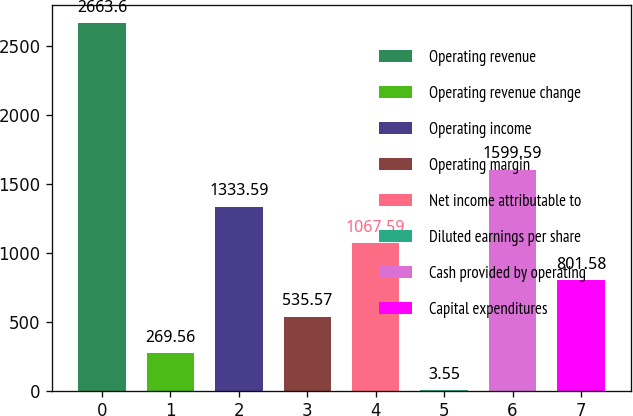<chart> <loc_0><loc_0><loc_500><loc_500><bar_chart><fcel>Operating revenue<fcel>Operating revenue change<fcel>Operating income<fcel>Operating margin<fcel>Net income attributable to<fcel>Diluted earnings per share<fcel>Cash provided by operating<fcel>Capital expenditures<nl><fcel>2663.6<fcel>269.56<fcel>1333.59<fcel>535.57<fcel>1067.59<fcel>3.55<fcel>1599.59<fcel>801.58<nl></chart> 